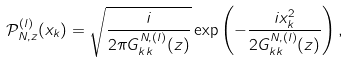<formula> <loc_0><loc_0><loc_500><loc_500>\mathcal { P } ^ { ( l ) } _ { N , z } ( x _ { k } ) = \sqrt { \frac { i } { 2 \pi G ^ { N , ( l ) } _ { k k } ( z ) } } \exp { \left ( - \frac { i x ^ { 2 } _ { k } } { 2 G ^ { N , ( l ) } _ { k k } ( z ) } \right ) } \, ,</formula> 